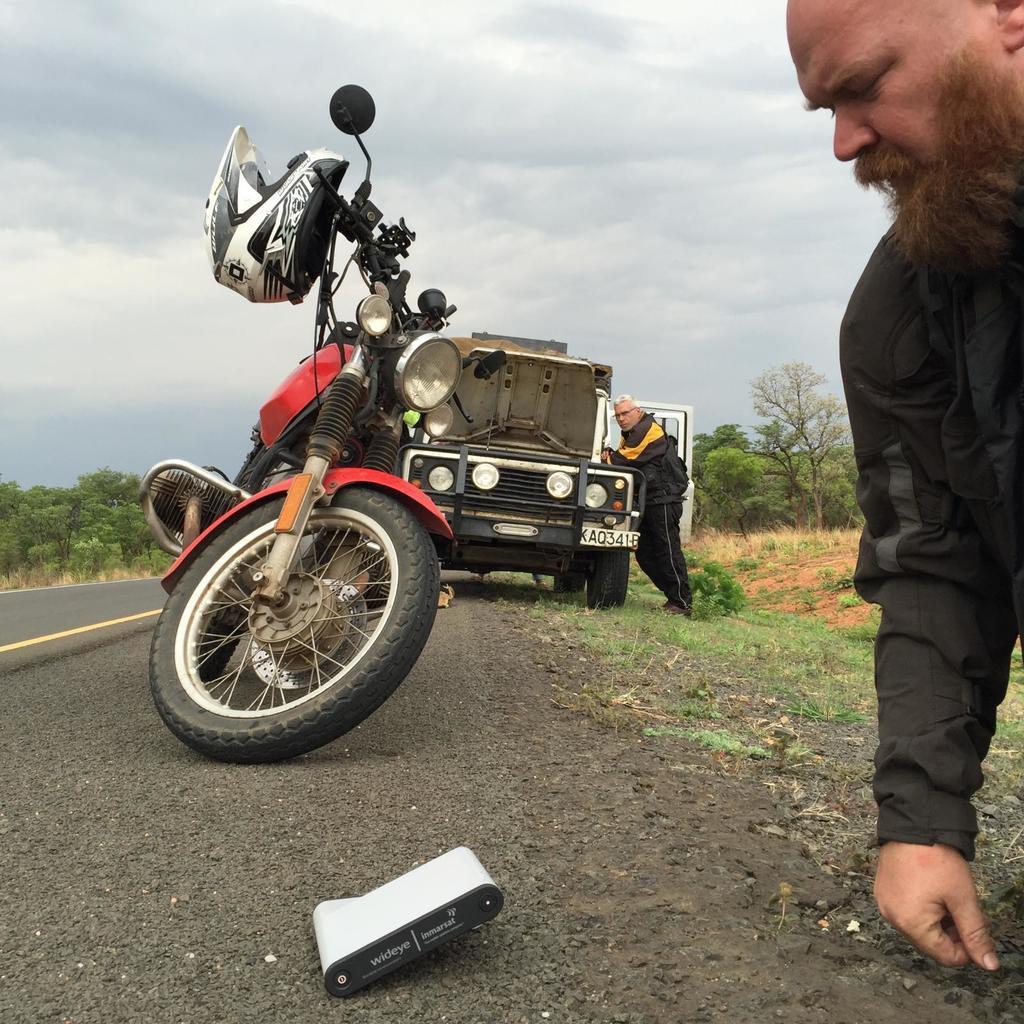Could you give a brief overview of what you see in this image? In this image I can see road and on it I can see yellow line, a red colour motorcycle and one more vehicle in background. I can also see two men and I can see both of them are wearing jackets. In background I can see trees, cloudy sky and I can see an object over here. I can also see white colour helmet over here. 